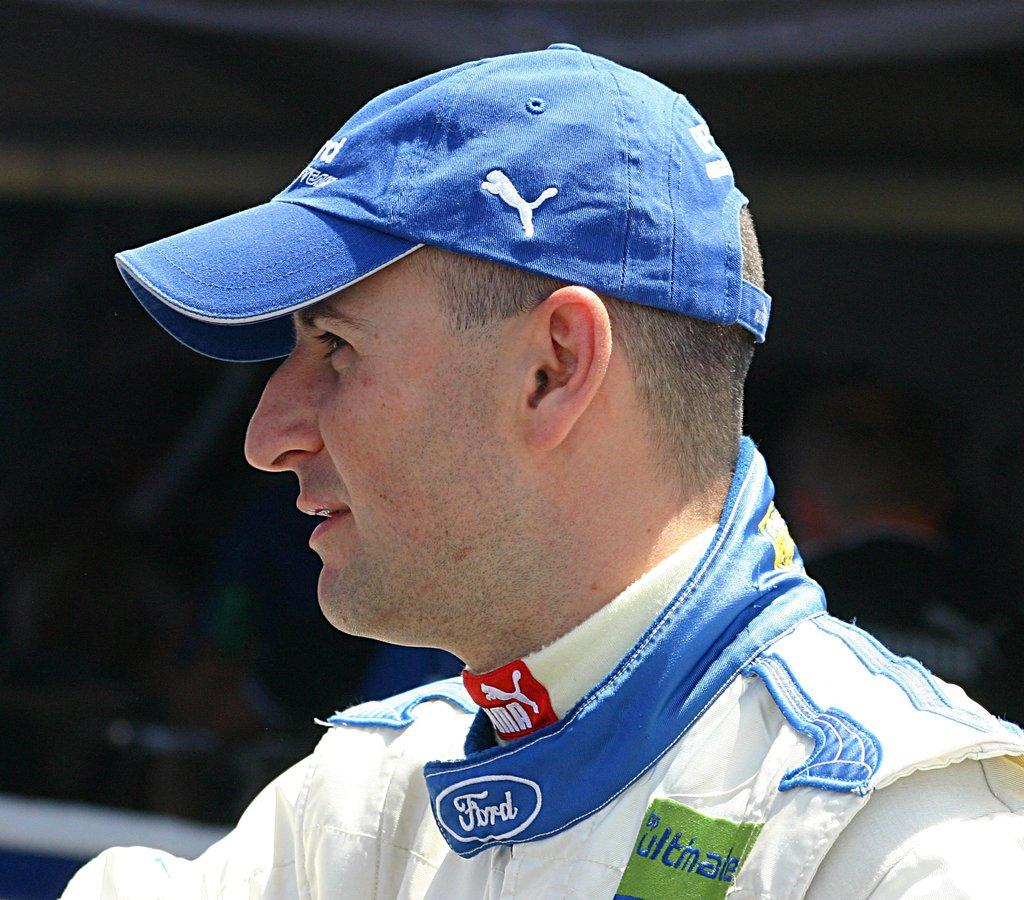<image>
Provide a brief description of the given image. A man wears various automobile logos including Ford. 